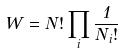Convert formula to latex. <formula><loc_0><loc_0><loc_500><loc_500>W = N ! \prod _ { i } \frac { 1 } { N _ { i } ! }</formula> 